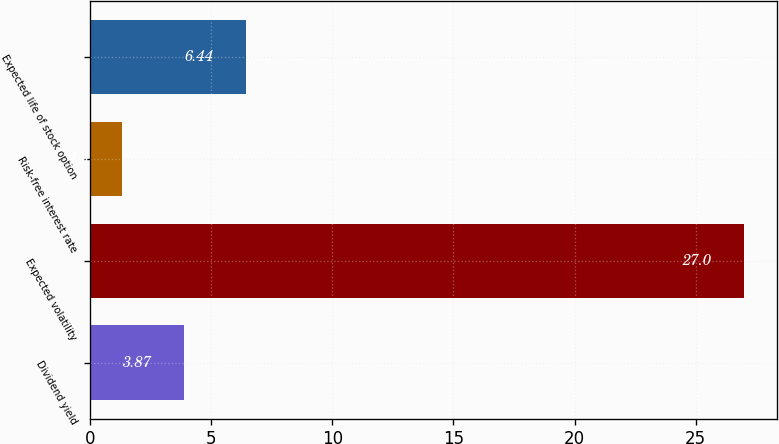<chart> <loc_0><loc_0><loc_500><loc_500><bar_chart><fcel>Dividend yield<fcel>Expected volatility<fcel>Risk-free interest rate<fcel>Expected life of stock option<nl><fcel>3.87<fcel>27<fcel>1.3<fcel>6.44<nl></chart> 